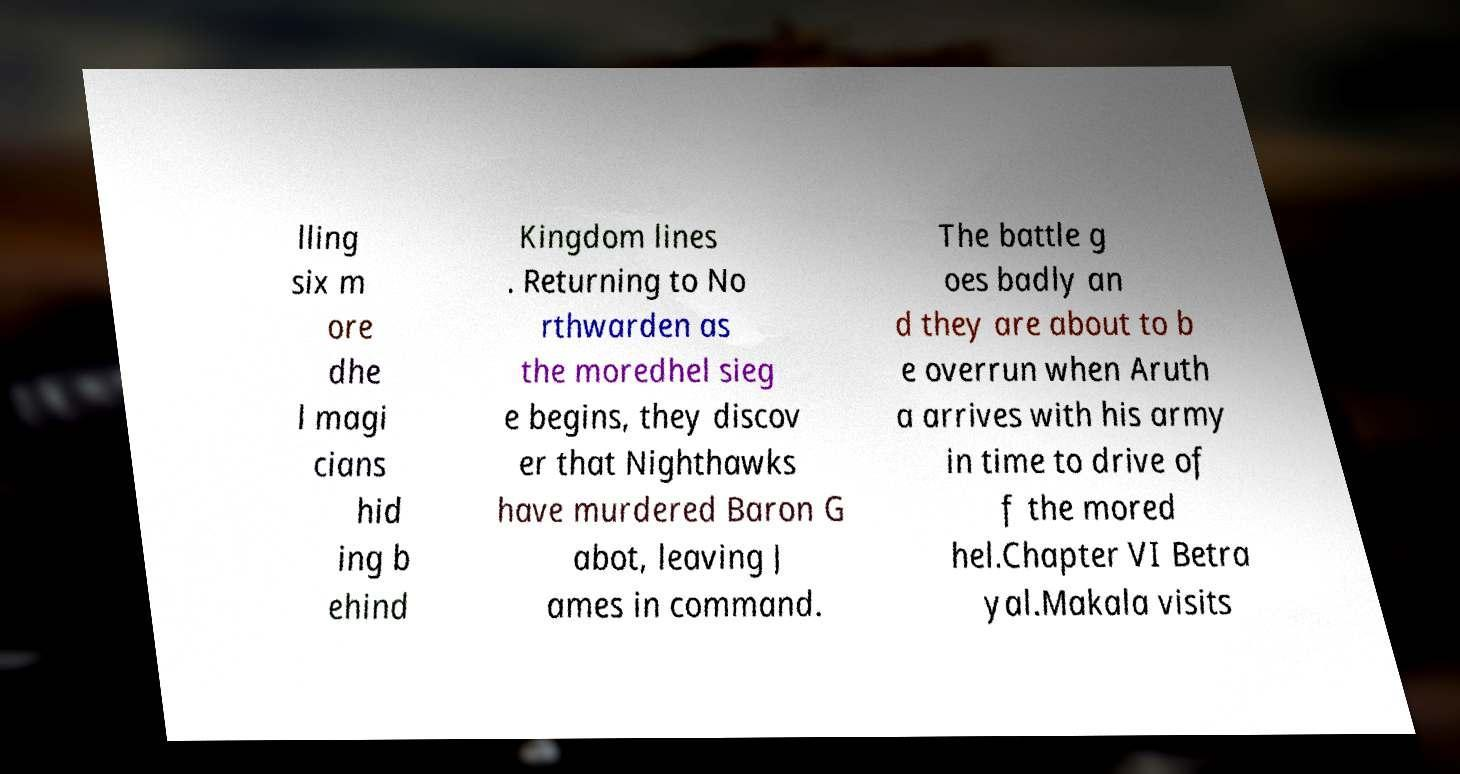Please identify and transcribe the text found in this image. lling six m ore dhe l magi cians hid ing b ehind Kingdom lines . Returning to No rthwarden as the moredhel sieg e begins, they discov er that Nighthawks have murdered Baron G abot, leaving J ames in command. The battle g oes badly an d they are about to b e overrun when Aruth a arrives with his army in time to drive of f the mored hel.Chapter VI Betra yal.Makala visits 